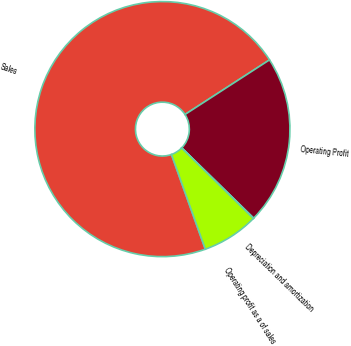Convert chart. <chart><loc_0><loc_0><loc_500><loc_500><pie_chart><fcel>Sales<fcel>Operating Profit<fcel>Depreciation and amortization<fcel>Operating profit as a of sales<nl><fcel>71.34%<fcel>21.44%<fcel>0.05%<fcel>7.18%<nl></chart> 